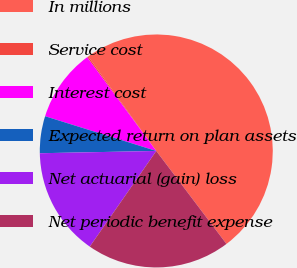Convert chart. <chart><loc_0><loc_0><loc_500><loc_500><pie_chart><fcel>In millions<fcel>Service cost<fcel>Interest cost<fcel>Expected return on plan assets<fcel>Net actuarial (gain) loss<fcel>Net periodic benefit expense<nl><fcel>49.64%<fcel>0.18%<fcel>10.07%<fcel>5.13%<fcel>15.02%<fcel>19.96%<nl></chart> 